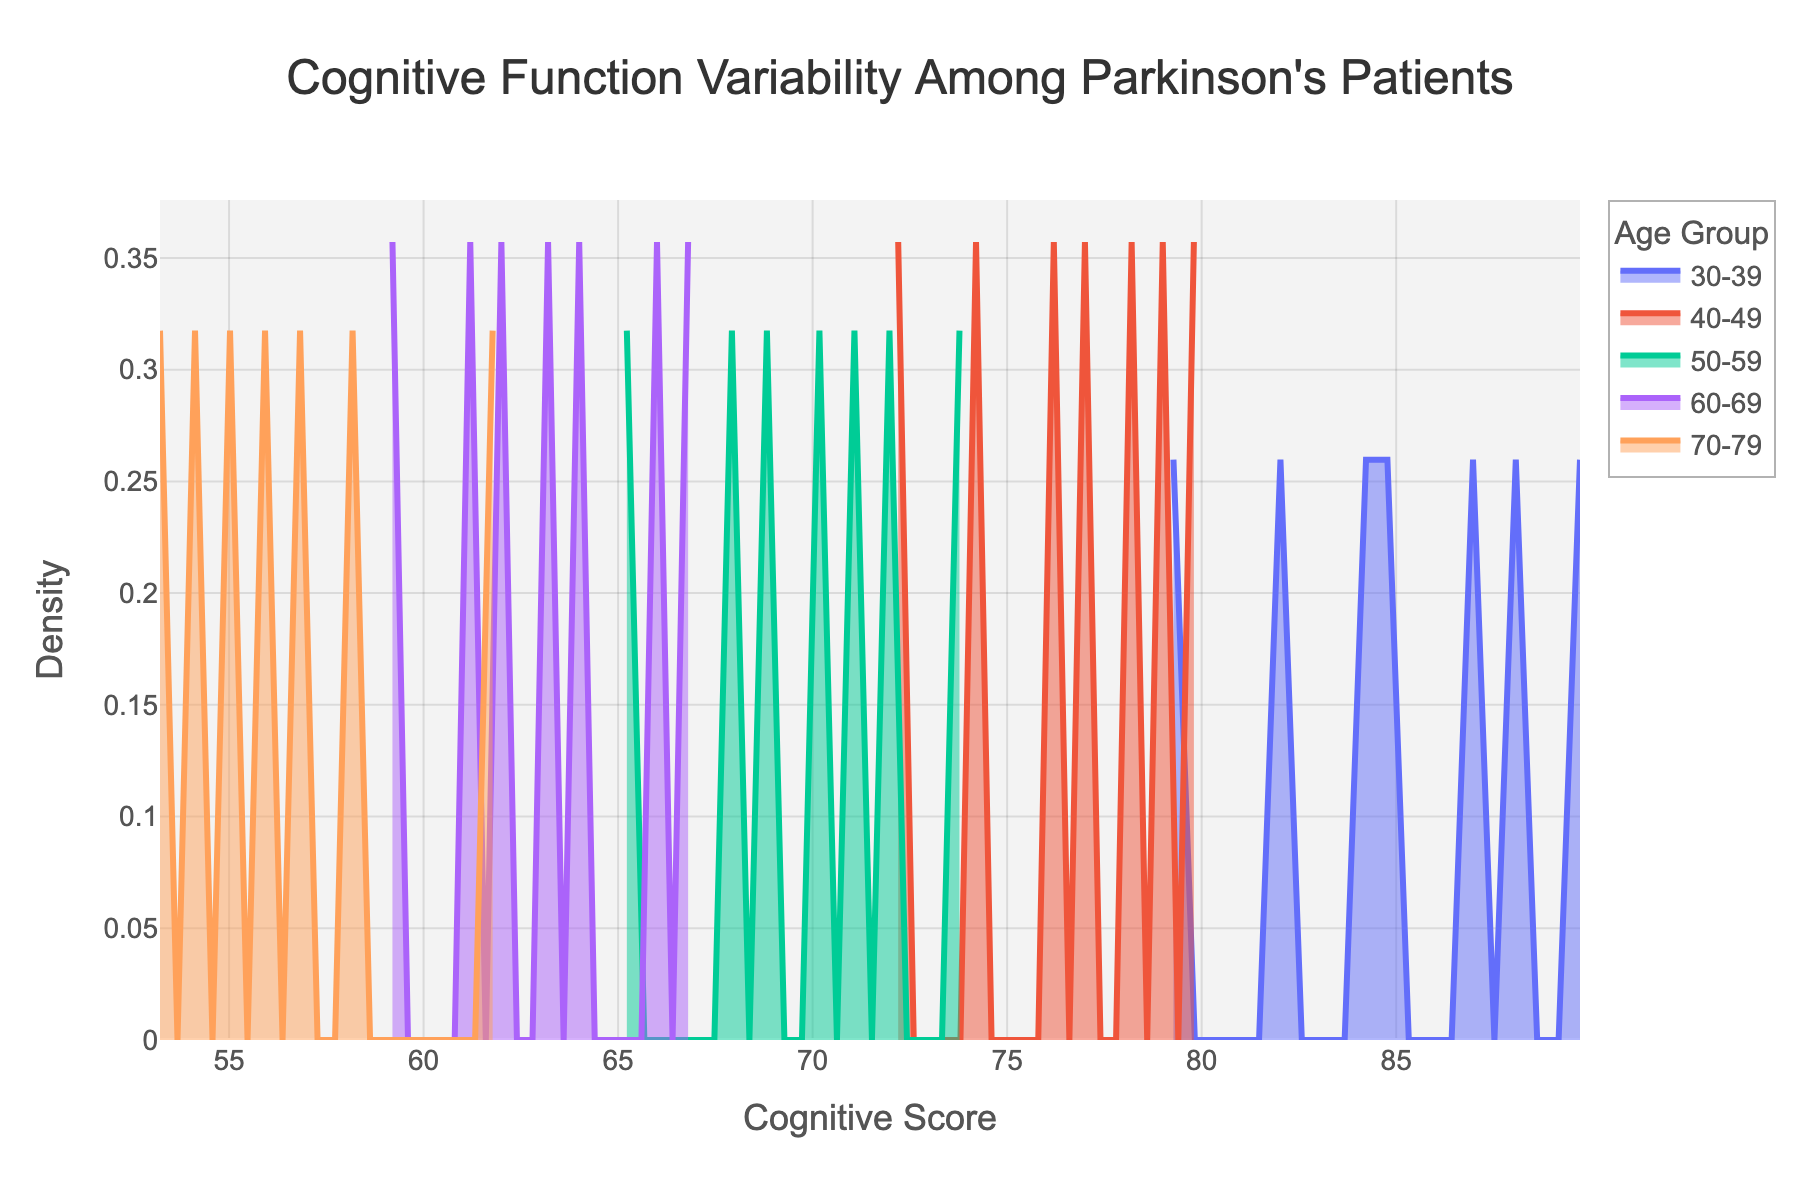What is the title of the figure? The title of the figure is prominently displayed at the top. It reads, "Cognitive Function Variability Among Parkinson's Patients".
Answer: Cognitive Function Variability Among Parkinson's Patients What does the x-axis represent? The x-axis label can be seen at the bottom of the figure and it indicates "Cognitive Score".
Answer: Cognitive Score Which age group has the peak density in the highest cognitive score range? By observing the density plot, the age group with the highest peak in the upper range (right side) of cognitive scores should be identified. The group corresponding to 30-39 shows the peak at the highest cognitive scores.
Answer: 30-39 How does the density for the 70-79 age group compare to the 30-39 age group at lower cognitive scores? By looking at the density plots, note the density values at lower cognitive scores for both age groups. The 70-79 group has higher density at lower cognitive scores compared to the 30-39 group, indicating more patients in this age group have lower scores.
Answer: Higher for 70-79 What does a higher peak in the density plot indicate about the cognitive scores for a specific age group? A higher peak in the density plot indicates a higher concentration of patients in that age group with similar cognitive scores, implying less variability.
Answer: Less variability in cognitive scores Which age group shows the most spread-out cognitive scores based on the density plots? Observing the width and spread-out nature of the density plots, the group with the widest spread indicates more variability. The 60-69 group displays a more spread-out density plot.
Answer: 60-69 Are there any age groups with overlapping cognitive score distributions? By carefully examining the peaks and the overlapping areas of the density plots, we can identify the age groups with overlapping cognitive scores. The 50-59 and 60-69 distributions overlap.
Answer: 50-59 and 60-69 Which age group has the lowest peak density in cognitive scores? Identify the age group with the smallest peak density by comparing the height of the peaks across all plots. The 70-79 group has the lowest peak density.
Answer: 70-79 What can you infer about the cognitive function variability among Parkinson's patients as they age from 30-39 to 70-79? The density plots show that the cognitive scores decrease and become more spread out as age increases, indicating that older age groups have lower average cognitive scores and greater variability.
Answer: Decrease in scores and increase in variability Which cognitive score range is most common for the 50-59 age group? Find the peak of the density plot for the 50-59 age group to determine the most common cognitive score range for this group. The most common range for the 50-59 age group is around 68-72.
Answer: 68-72 